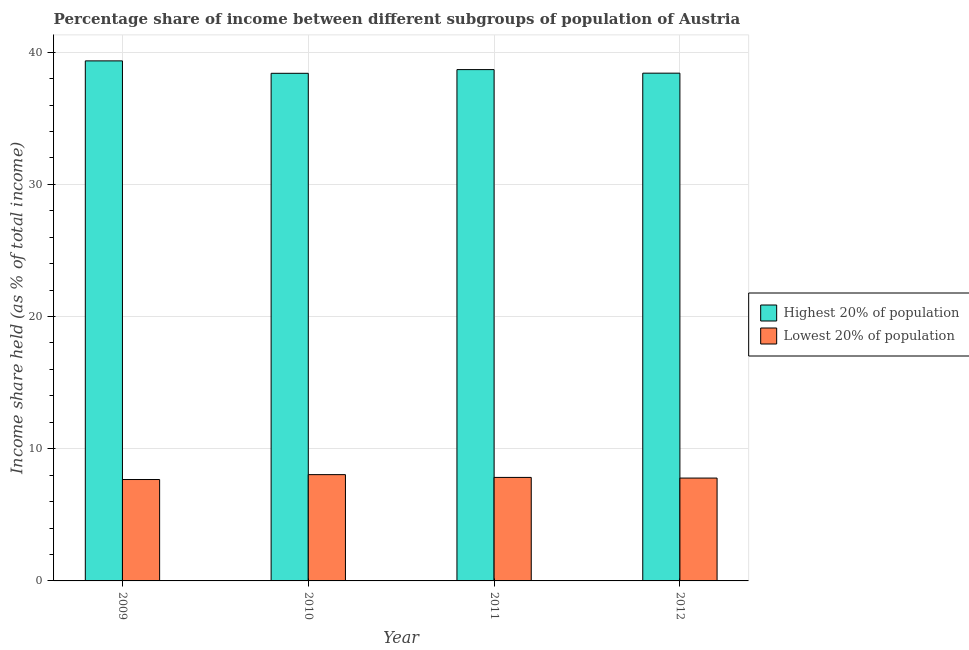How many bars are there on the 4th tick from the left?
Ensure brevity in your answer.  2. How many bars are there on the 4th tick from the right?
Offer a terse response. 2. In how many cases, is the number of bars for a given year not equal to the number of legend labels?
Your answer should be very brief. 0. What is the income share held by lowest 20% of the population in 2009?
Your answer should be very brief. 7.67. Across all years, what is the maximum income share held by highest 20% of the population?
Provide a succinct answer. 39.34. Across all years, what is the minimum income share held by highest 20% of the population?
Your response must be concise. 38.4. What is the total income share held by highest 20% of the population in the graph?
Offer a very short reply. 154.83. What is the difference between the income share held by lowest 20% of the population in 2009 and that in 2012?
Your answer should be compact. -0.11. What is the difference between the income share held by lowest 20% of the population in 2012 and the income share held by highest 20% of the population in 2010?
Make the answer very short. -0.26. What is the average income share held by highest 20% of the population per year?
Give a very brief answer. 38.71. What is the ratio of the income share held by lowest 20% of the population in 2010 to that in 2012?
Offer a terse response. 1.03. Is the income share held by lowest 20% of the population in 2010 less than that in 2011?
Offer a terse response. No. What is the difference between the highest and the second highest income share held by lowest 20% of the population?
Offer a very short reply. 0.21. What is the difference between the highest and the lowest income share held by highest 20% of the population?
Keep it short and to the point. 0.94. What does the 1st bar from the left in 2010 represents?
Offer a terse response. Highest 20% of population. What does the 1st bar from the right in 2010 represents?
Ensure brevity in your answer.  Lowest 20% of population. How many bars are there?
Offer a very short reply. 8. How many years are there in the graph?
Offer a terse response. 4. Does the graph contain any zero values?
Ensure brevity in your answer.  No. Where does the legend appear in the graph?
Give a very brief answer. Center right. What is the title of the graph?
Offer a very short reply. Percentage share of income between different subgroups of population of Austria. What is the label or title of the Y-axis?
Provide a succinct answer. Income share held (as % of total income). What is the Income share held (as % of total income) in Highest 20% of population in 2009?
Your answer should be very brief. 39.34. What is the Income share held (as % of total income) in Lowest 20% of population in 2009?
Offer a very short reply. 7.67. What is the Income share held (as % of total income) in Highest 20% of population in 2010?
Offer a very short reply. 38.4. What is the Income share held (as % of total income) in Lowest 20% of population in 2010?
Your answer should be very brief. 8.04. What is the Income share held (as % of total income) in Highest 20% of population in 2011?
Your answer should be very brief. 38.68. What is the Income share held (as % of total income) in Lowest 20% of population in 2011?
Provide a short and direct response. 7.83. What is the Income share held (as % of total income) of Highest 20% of population in 2012?
Your answer should be very brief. 38.41. What is the Income share held (as % of total income) in Lowest 20% of population in 2012?
Provide a succinct answer. 7.78. Across all years, what is the maximum Income share held (as % of total income) of Highest 20% of population?
Provide a short and direct response. 39.34. Across all years, what is the maximum Income share held (as % of total income) of Lowest 20% of population?
Give a very brief answer. 8.04. Across all years, what is the minimum Income share held (as % of total income) in Highest 20% of population?
Provide a short and direct response. 38.4. Across all years, what is the minimum Income share held (as % of total income) in Lowest 20% of population?
Your answer should be compact. 7.67. What is the total Income share held (as % of total income) in Highest 20% of population in the graph?
Provide a short and direct response. 154.83. What is the total Income share held (as % of total income) in Lowest 20% of population in the graph?
Provide a short and direct response. 31.32. What is the difference between the Income share held (as % of total income) in Highest 20% of population in 2009 and that in 2010?
Give a very brief answer. 0.94. What is the difference between the Income share held (as % of total income) in Lowest 20% of population in 2009 and that in 2010?
Your response must be concise. -0.37. What is the difference between the Income share held (as % of total income) in Highest 20% of population in 2009 and that in 2011?
Offer a terse response. 0.66. What is the difference between the Income share held (as % of total income) of Lowest 20% of population in 2009 and that in 2011?
Give a very brief answer. -0.16. What is the difference between the Income share held (as % of total income) of Lowest 20% of population in 2009 and that in 2012?
Make the answer very short. -0.11. What is the difference between the Income share held (as % of total income) in Highest 20% of population in 2010 and that in 2011?
Offer a terse response. -0.28. What is the difference between the Income share held (as % of total income) in Lowest 20% of population in 2010 and that in 2011?
Keep it short and to the point. 0.21. What is the difference between the Income share held (as % of total income) in Highest 20% of population in 2010 and that in 2012?
Your response must be concise. -0.01. What is the difference between the Income share held (as % of total income) in Lowest 20% of population in 2010 and that in 2012?
Keep it short and to the point. 0.26. What is the difference between the Income share held (as % of total income) of Highest 20% of population in 2011 and that in 2012?
Provide a short and direct response. 0.27. What is the difference between the Income share held (as % of total income) of Lowest 20% of population in 2011 and that in 2012?
Your response must be concise. 0.05. What is the difference between the Income share held (as % of total income) in Highest 20% of population in 2009 and the Income share held (as % of total income) in Lowest 20% of population in 2010?
Ensure brevity in your answer.  31.3. What is the difference between the Income share held (as % of total income) in Highest 20% of population in 2009 and the Income share held (as % of total income) in Lowest 20% of population in 2011?
Keep it short and to the point. 31.51. What is the difference between the Income share held (as % of total income) of Highest 20% of population in 2009 and the Income share held (as % of total income) of Lowest 20% of population in 2012?
Your answer should be very brief. 31.56. What is the difference between the Income share held (as % of total income) of Highest 20% of population in 2010 and the Income share held (as % of total income) of Lowest 20% of population in 2011?
Provide a succinct answer. 30.57. What is the difference between the Income share held (as % of total income) in Highest 20% of population in 2010 and the Income share held (as % of total income) in Lowest 20% of population in 2012?
Make the answer very short. 30.62. What is the difference between the Income share held (as % of total income) in Highest 20% of population in 2011 and the Income share held (as % of total income) in Lowest 20% of population in 2012?
Provide a short and direct response. 30.9. What is the average Income share held (as % of total income) of Highest 20% of population per year?
Offer a very short reply. 38.71. What is the average Income share held (as % of total income) of Lowest 20% of population per year?
Make the answer very short. 7.83. In the year 2009, what is the difference between the Income share held (as % of total income) in Highest 20% of population and Income share held (as % of total income) in Lowest 20% of population?
Keep it short and to the point. 31.67. In the year 2010, what is the difference between the Income share held (as % of total income) of Highest 20% of population and Income share held (as % of total income) of Lowest 20% of population?
Keep it short and to the point. 30.36. In the year 2011, what is the difference between the Income share held (as % of total income) of Highest 20% of population and Income share held (as % of total income) of Lowest 20% of population?
Make the answer very short. 30.85. In the year 2012, what is the difference between the Income share held (as % of total income) in Highest 20% of population and Income share held (as % of total income) in Lowest 20% of population?
Make the answer very short. 30.63. What is the ratio of the Income share held (as % of total income) in Highest 20% of population in 2009 to that in 2010?
Your answer should be very brief. 1.02. What is the ratio of the Income share held (as % of total income) in Lowest 20% of population in 2009 to that in 2010?
Offer a very short reply. 0.95. What is the ratio of the Income share held (as % of total income) of Highest 20% of population in 2009 to that in 2011?
Keep it short and to the point. 1.02. What is the ratio of the Income share held (as % of total income) in Lowest 20% of population in 2009 to that in 2011?
Your response must be concise. 0.98. What is the ratio of the Income share held (as % of total income) of Highest 20% of population in 2009 to that in 2012?
Your answer should be very brief. 1.02. What is the ratio of the Income share held (as % of total income) in Lowest 20% of population in 2009 to that in 2012?
Your answer should be very brief. 0.99. What is the ratio of the Income share held (as % of total income) in Lowest 20% of population in 2010 to that in 2011?
Offer a terse response. 1.03. What is the ratio of the Income share held (as % of total income) of Lowest 20% of population in 2010 to that in 2012?
Make the answer very short. 1.03. What is the ratio of the Income share held (as % of total income) in Highest 20% of population in 2011 to that in 2012?
Your answer should be very brief. 1.01. What is the ratio of the Income share held (as % of total income) in Lowest 20% of population in 2011 to that in 2012?
Provide a succinct answer. 1.01. What is the difference between the highest and the second highest Income share held (as % of total income) in Highest 20% of population?
Offer a terse response. 0.66. What is the difference between the highest and the second highest Income share held (as % of total income) of Lowest 20% of population?
Ensure brevity in your answer.  0.21. What is the difference between the highest and the lowest Income share held (as % of total income) of Highest 20% of population?
Your answer should be compact. 0.94. What is the difference between the highest and the lowest Income share held (as % of total income) of Lowest 20% of population?
Give a very brief answer. 0.37. 